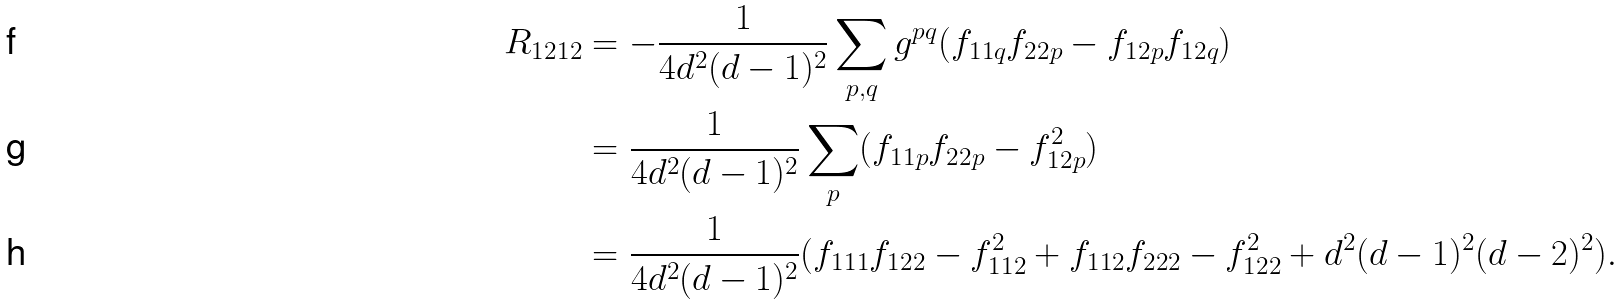Convert formula to latex. <formula><loc_0><loc_0><loc_500><loc_500>R _ { 1 2 1 2 } & = - \frac { 1 } { 4 d ^ { 2 } ( d - 1 ) ^ { 2 } } \sum _ { p , q } g ^ { p q } ( f _ { 1 1 q } f _ { 2 2 p } - f _ { 1 2 p } f _ { 1 2 q } ) \\ & = \frac { 1 } { 4 d ^ { 2 } ( d - 1 ) ^ { 2 } } \sum _ { p } ( f _ { 1 1 p } f _ { 2 2 p } - f _ { 1 2 p } ^ { 2 } ) \\ & = \frac { 1 } { 4 d ^ { 2 } ( d - 1 ) ^ { 2 } } ( f _ { 1 1 1 } f _ { 1 2 2 } - f _ { 1 1 2 } ^ { 2 } + f _ { 1 1 2 } f _ { 2 2 2 } - f _ { 1 2 2 } ^ { 2 } + d ^ { 2 } ( d - 1 ) ^ { 2 } ( d - 2 ) ^ { 2 } ) .</formula> 